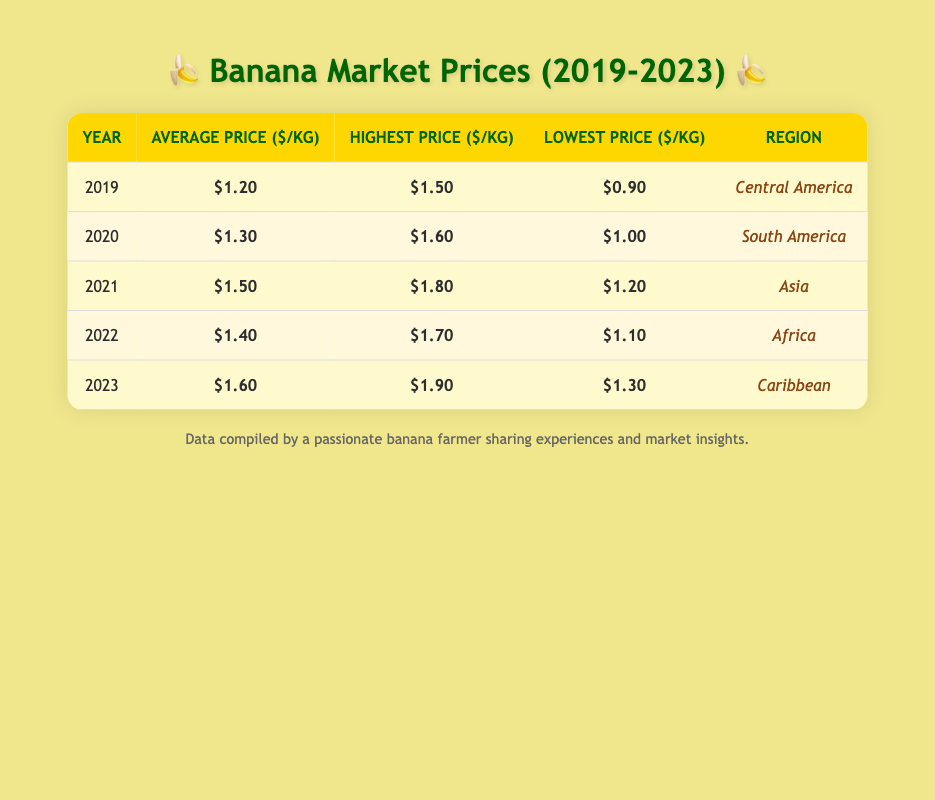What was the highest price per kilogram of bananas in 2021? The highest price in the year 2021, as listed in the table, is $1.80.
Answer: $1.80 In which region was the lowest average price per kilogram of bananas recorded during the five years? The lowest average price per kilogram was recorded in Central America in 2019, at $1.20.
Answer: Central America What is the average price per kilogram of bananas from 2019 to 2023? To find the average, add all the average prices: (1.20 + 1.30 + 1.50 + 1.40 + 1.60) = 6.00. Then, divide by the number of years (5): 6.00 / 5 = 1.20.
Answer: $1.20 Was the average price of bananas in 2022 higher than that in 2020? The average price in 2022 is $1.40, while that in 2020 is $1.30. Since $1.40 is greater than $1.30, the statement is true.
Answer: Yes What was the trend in average banana prices from 2019 to 2023 based on the table? Starting from 2019 with $1.20, the average prices increased to $1.30 in 2020, $1.50 in 2021, decreased slightly to $1.40 in 2022, and then rose again to $1.60 in 2023. Thus, the trend shows an overall increase in prices despite a slight dip in 2022.
Answer: Increasing In which year and region was the highest recorded price for bananas, and what was that price? The highest recorded price for bananas was in 2023 in the Caribbean at $1.90.
Answer: 2023, Caribbean, $1.90 Which region had the most significant fluctuation in banana prices over these five years, based on the difference between its highest and lowest prices? To find this, identify the highest and lowest prices in each region: Central America: $1.50 - $0.90 = $0.60, South America: $1.60 - $1.00 = $0.60, Asia: $1.80 - $1.20 = $0.60, Africa: $1.70 - $1.10 = $0.60, Caribbean: $1.90 - $1.30 = $0.60. All regions have the same fluctuation of $0.60, revealing that none had a more significant fluctuation.
Answer: No region had more significant fluctuation 